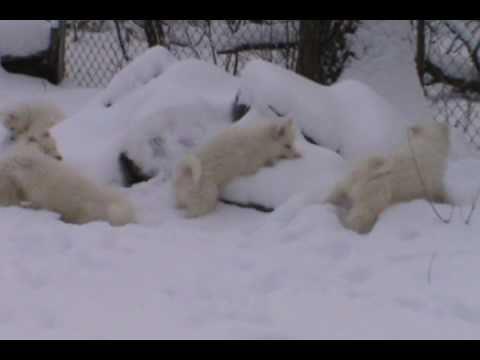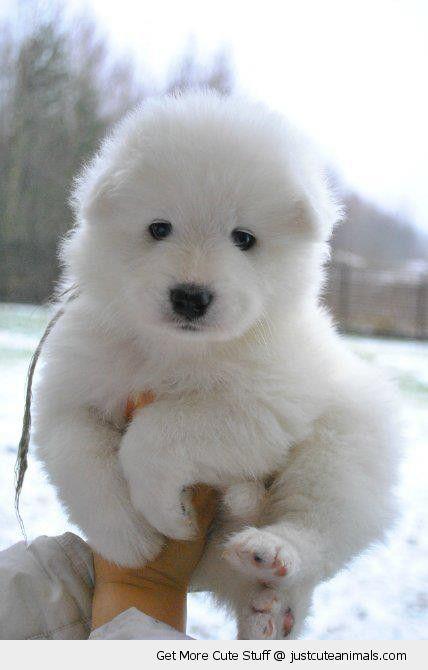The first image is the image on the left, the second image is the image on the right. Examine the images to the left and right. Is the description "There are exactly three dogs." accurate? Answer yes or no. No. The first image is the image on the left, the second image is the image on the right. Evaluate the accuracy of this statement regarding the images: "One image shows two white dogs close together in the snow, and the other shows a single white dog in a snowy scene.". Is it true? Answer yes or no. No. 